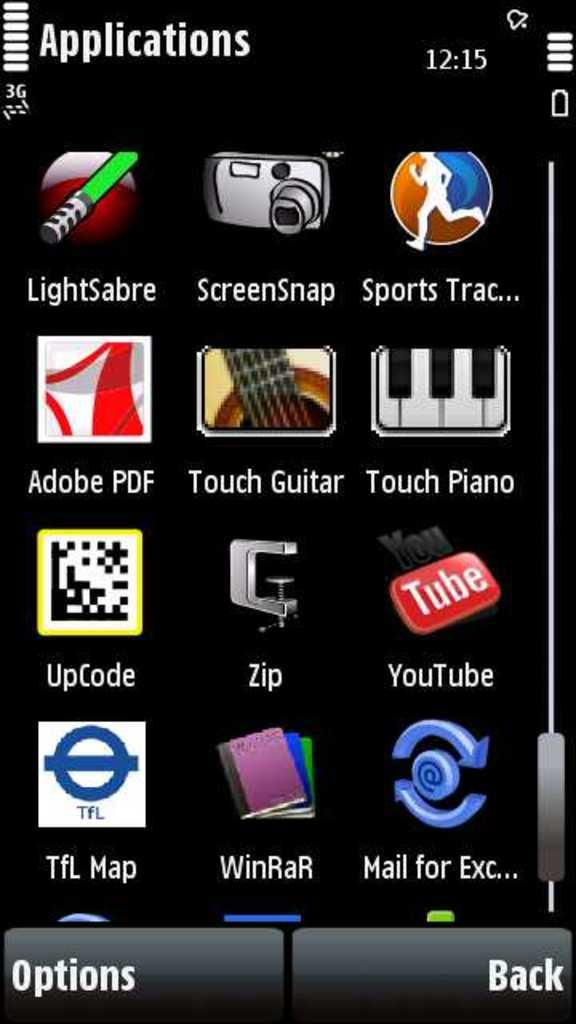<image>
Give a short and clear explanation of the subsequent image. A phone screen full of apps, one of which is called Lightsabre. 